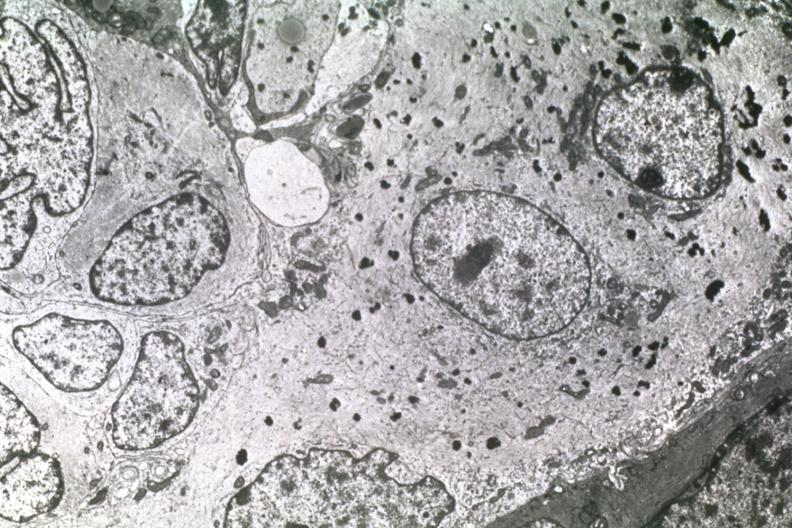s view of head with scalp present?
Answer the question using a single word or phrase. No 